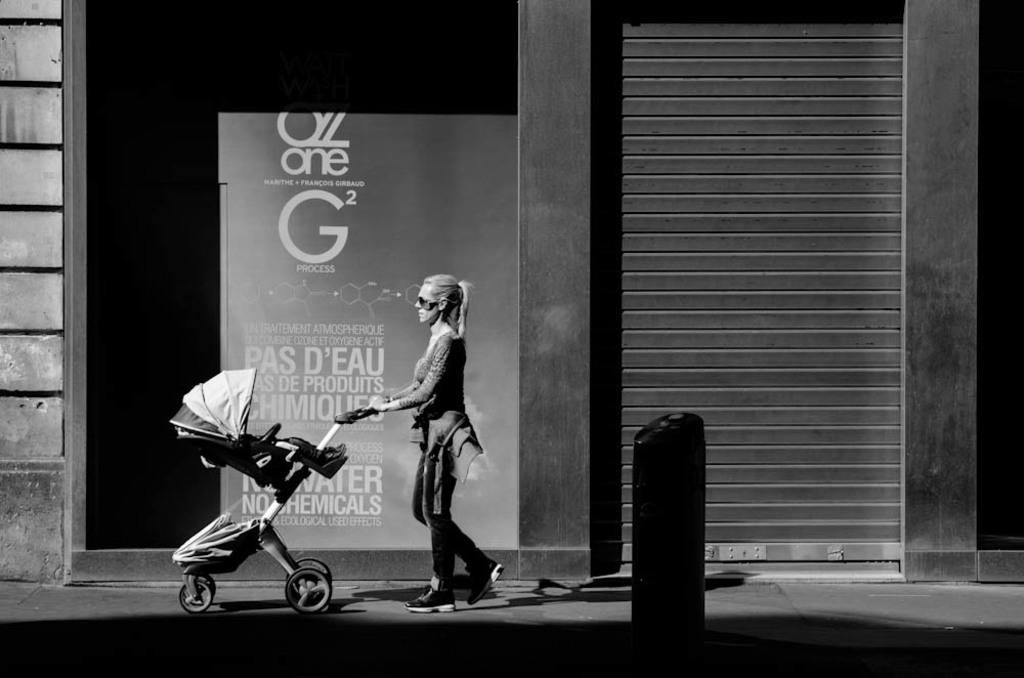What is the person in the image doing? The person is walking in the image. What is the person holding while walking? The person is holding a trolley. What can be seen in the background of the image? There is a building in the background of the image. What is the color scheme of the image? The image is in black and white. What type of minister is standing in front of the home in the image? There is no minister or home present in the image; it features a person walking with a trolley and a building in the background. 